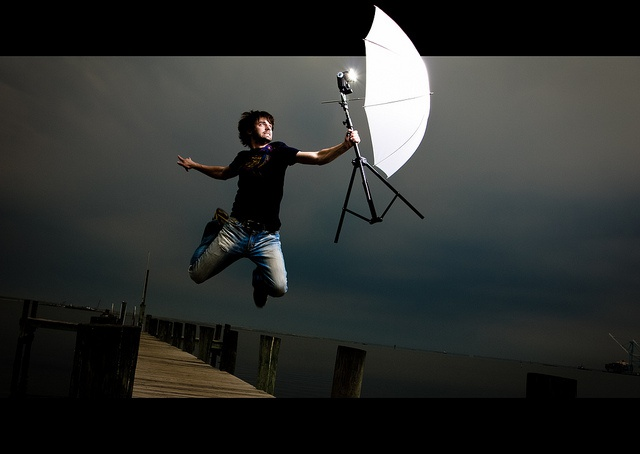Describe the objects in this image and their specific colors. I can see people in black, gray, darkgray, and maroon tones and umbrella in black, white, gray, and darkgray tones in this image. 